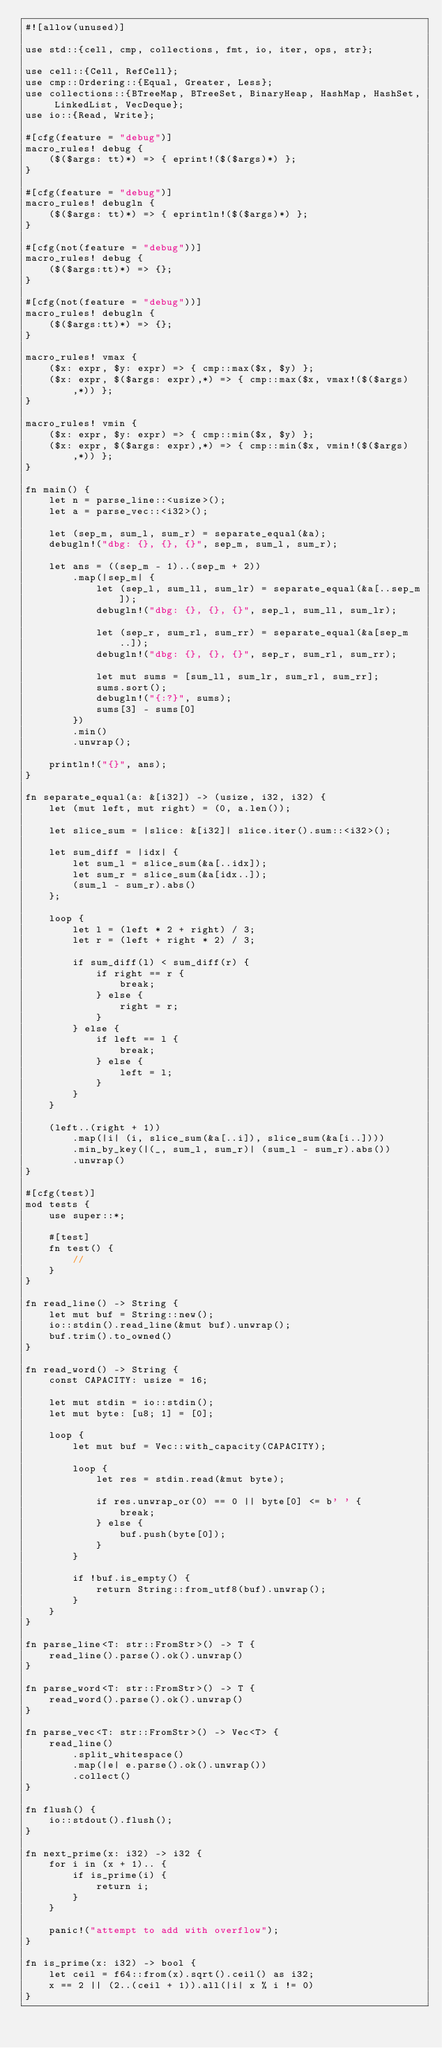Convert code to text. <code><loc_0><loc_0><loc_500><loc_500><_Rust_>#![allow(unused)]

use std::{cell, cmp, collections, fmt, io, iter, ops, str};

use cell::{Cell, RefCell};
use cmp::Ordering::{Equal, Greater, Less};
use collections::{BTreeMap, BTreeSet, BinaryHeap, HashMap, HashSet, LinkedList, VecDeque};
use io::{Read, Write};

#[cfg(feature = "debug")]
macro_rules! debug {
    ($($args: tt)*) => { eprint!($($args)*) };
}

#[cfg(feature = "debug")]
macro_rules! debugln {
    ($($args: tt)*) => { eprintln!($($args)*) };
}

#[cfg(not(feature = "debug"))]
macro_rules! debug {
    ($($args:tt)*) => {};
}

#[cfg(not(feature = "debug"))]
macro_rules! debugln {
    ($($args:tt)*) => {};
}

macro_rules! vmax {
    ($x: expr, $y: expr) => { cmp::max($x, $y) };
    ($x: expr, $($args: expr),*) => { cmp::max($x, vmax!($($args),*)) };
}

macro_rules! vmin {
    ($x: expr, $y: expr) => { cmp::min($x, $y) };
    ($x: expr, $($args: expr),*) => { cmp::min($x, vmin!($($args),*)) };
}

fn main() {
    let n = parse_line::<usize>();
    let a = parse_vec::<i32>();

    let (sep_m, sum_l, sum_r) = separate_equal(&a);
    debugln!("dbg: {}, {}, {}", sep_m, sum_l, sum_r);

    let ans = ((sep_m - 1)..(sep_m + 2))
        .map(|sep_m| {
            let (sep_l, sum_ll, sum_lr) = separate_equal(&a[..sep_m]);
            debugln!("dbg: {}, {}, {}", sep_l, sum_ll, sum_lr);

            let (sep_r, sum_rl, sum_rr) = separate_equal(&a[sep_m..]);
            debugln!("dbg: {}, {}, {}", sep_r, sum_rl, sum_rr);

            let mut sums = [sum_ll, sum_lr, sum_rl, sum_rr];
            sums.sort();
            debugln!("{:?}", sums);
            sums[3] - sums[0]
        })
        .min()
        .unwrap();

    println!("{}", ans);
}

fn separate_equal(a: &[i32]) -> (usize, i32, i32) {
    let (mut left, mut right) = (0, a.len());

    let slice_sum = |slice: &[i32]| slice.iter().sum::<i32>();

    let sum_diff = |idx| {
        let sum_l = slice_sum(&a[..idx]);
        let sum_r = slice_sum(&a[idx..]);
        (sum_l - sum_r).abs()
    };

    loop {
        let l = (left * 2 + right) / 3;
        let r = (left + right * 2) / 3;

        if sum_diff(l) < sum_diff(r) {
            if right == r {
                break;
            } else {
                right = r;
            }
        } else {
            if left == l {
                break;
            } else {
                left = l;
            }
        }
    }

    (left..(right + 1))
        .map(|i| (i, slice_sum(&a[..i]), slice_sum(&a[i..])))
        .min_by_key(|(_, sum_l, sum_r)| (sum_l - sum_r).abs())
        .unwrap()
}

#[cfg(test)]
mod tests {
    use super::*;

    #[test]
    fn test() {
        //
    }
}

fn read_line() -> String {
    let mut buf = String::new();
    io::stdin().read_line(&mut buf).unwrap();
    buf.trim().to_owned()
}

fn read_word() -> String {
    const CAPACITY: usize = 16;

    let mut stdin = io::stdin();
    let mut byte: [u8; 1] = [0];

    loop {
        let mut buf = Vec::with_capacity(CAPACITY);

        loop {
            let res = stdin.read(&mut byte);

            if res.unwrap_or(0) == 0 || byte[0] <= b' ' {
                break;
            } else {
                buf.push(byte[0]);
            }
        }

        if !buf.is_empty() {
            return String::from_utf8(buf).unwrap();
        }
    }
}

fn parse_line<T: str::FromStr>() -> T {
    read_line().parse().ok().unwrap()
}

fn parse_word<T: str::FromStr>() -> T {
    read_word().parse().ok().unwrap()
}

fn parse_vec<T: str::FromStr>() -> Vec<T> {
    read_line()
        .split_whitespace()
        .map(|e| e.parse().ok().unwrap())
        .collect()
}

fn flush() {
    io::stdout().flush();
}

fn next_prime(x: i32) -> i32 {
    for i in (x + 1).. {
        if is_prime(i) {
            return i;
        }
    }

    panic!("attempt to add with overflow");
}

fn is_prime(x: i32) -> bool {
    let ceil = f64::from(x).sqrt().ceil() as i32;
    x == 2 || (2..(ceil + 1)).all(|i| x % i != 0)
}
</code> 